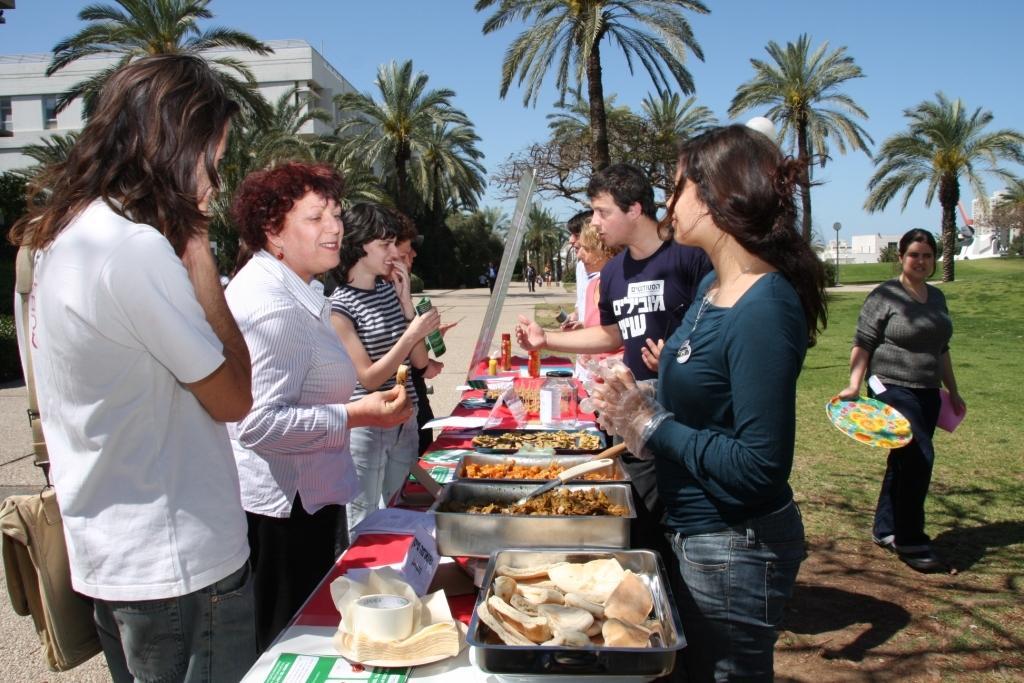In one or two sentences, can you explain what this image depicts? At the top we can see sky. This is a building and these are trees. We can see few persons standing infront of a table and on the table we can see lot many dishes, jars and a paper. Here we can see a woman is standing by holding a plate in her hand. This is road. We can see few persons walking. This is a fresh green grass. 